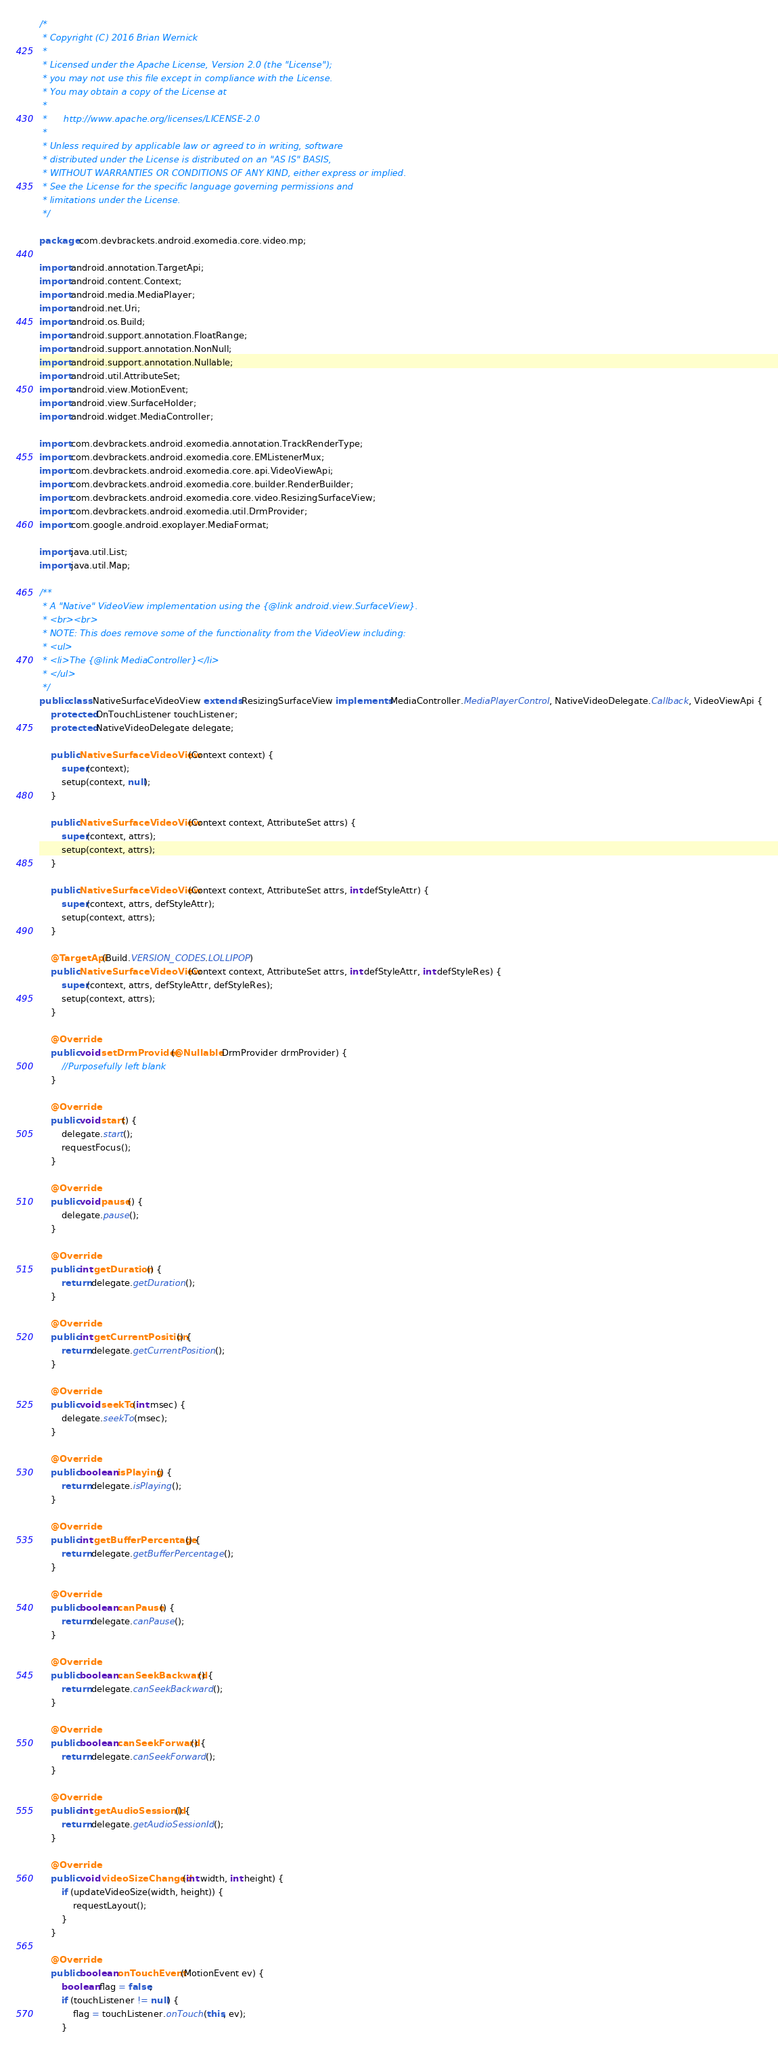<code> <loc_0><loc_0><loc_500><loc_500><_Java_>/*
 * Copyright (C) 2016 Brian Wernick
 *
 * Licensed under the Apache License, Version 2.0 (the "License");
 * you may not use this file except in compliance with the License.
 * You may obtain a copy of the License at
 *
 *      http://www.apache.org/licenses/LICENSE-2.0
 *
 * Unless required by applicable law or agreed to in writing, software
 * distributed under the License is distributed on an "AS IS" BASIS,
 * WITHOUT WARRANTIES OR CONDITIONS OF ANY KIND, either express or implied.
 * See the License for the specific language governing permissions and
 * limitations under the License.
 */

package com.devbrackets.android.exomedia.core.video.mp;

import android.annotation.TargetApi;
import android.content.Context;
import android.media.MediaPlayer;
import android.net.Uri;
import android.os.Build;
import android.support.annotation.FloatRange;
import android.support.annotation.NonNull;
import android.support.annotation.Nullable;
import android.util.AttributeSet;
import android.view.MotionEvent;
import android.view.SurfaceHolder;
import android.widget.MediaController;

import com.devbrackets.android.exomedia.annotation.TrackRenderType;
import com.devbrackets.android.exomedia.core.EMListenerMux;
import com.devbrackets.android.exomedia.core.api.VideoViewApi;
import com.devbrackets.android.exomedia.core.builder.RenderBuilder;
import com.devbrackets.android.exomedia.core.video.ResizingSurfaceView;
import com.devbrackets.android.exomedia.util.DrmProvider;
import com.google.android.exoplayer.MediaFormat;

import java.util.List;
import java.util.Map;

/**
 * A "Native" VideoView implementation using the {@link android.view.SurfaceView}.
 * <br><br>
 * NOTE: This does remove some of the functionality from the VideoView including:
 * <ul>
 * <li>The {@link MediaController}</li>
 * </ul>
 */
public class NativeSurfaceVideoView extends ResizingSurfaceView implements MediaController.MediaPlayerControl, NativeVideoDelegate.Callback, VideoViewApi {
    protected OnTouchListener touchListener;
    protected NativeVideoDelegate delegate;

    public NativeSurfaceVideoView(Context context) {
        super(context);
        setup(context, null);
    }

    public NativeSurfaceVideoView(Context context, AttributeSet attrs) {
        super(context, attrs);
        setup(context, attrs);
    }

    public NativeSurfaceVideoView(Context context, AttributeSet attrs, int defStyleAttr) {
        super(context, attrs, defStyleAttr);
        setup(context, attrs);
    }

    @TargetApi(Build.VERSION_CODES.LOLLIPOP)
    public NativeSurfaceVideoView(Context context, AttributeSet attrs, int defStyleAttr, int defStyleRes) {
        super(context, attrs, defStyleAttr, defStyleRes);
        setup(context, attrs);
    }

    @Override
    public void setDrmProvider(@Nullable DrmProvider drmProvider) {
        //Purposefully left blank
    }

    @Override
    public void start() {
        delegate.start();
        requestFocus();
    }

    @Override
    public void pause() {
        delegate.pause();
    }

    @Override
    public int getDuration() {
        return delegate.getDuration();
    }

    @Override
    public int getCurrentPosition() {
        return delegate.getCurrentPosition();
    }

    @Override
    public void seekTo(int msec) {
        delegate.seekTo(msec);
    }

    @Override
    public boolean isPlaying() {
        return delegate.isPlaying();
    }

    @Override
    public int getBufferPercentage() {
        return delegate.getBufferPercentage();
    }

    @Override
    public boolean canPause() {
        return delegate.canPause();
    }

    @Override
    public boolean canSeekBackward() {
        return delegate.canSeekBackward();
    }

    @Override
    public boolean canSeekForward() {
        return delegate.canSeekForward();
    }

    @Override
    public int getAudioSessionId() {
        return delegate.getAudioSessionId();
    }

    @Override
    public void videoSizeChanged(int width, int height) {
        if (updateVideoSize(width, height)) {
            requestLayout();
        }
    }

    @Override
    public boolean onTouchEvent(MotionEvent ev) {
        boolean flag = false;
        if (touchListener != null) {
            flag = touchListener.onTouch(this, ev);
        }
</code> 